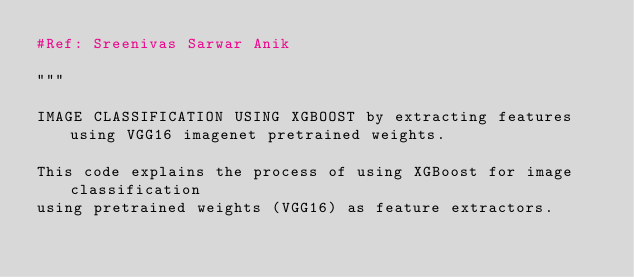<code> <loc_0><loc_0><loc_500><loc_500><_Python_>#Ref: Sreenivas Sarwar Anik

"""

IMAGE CLASSIFICATION USING XGBOOST by extracting features using VGG16 imagenet pretrained weights.

This code explains the process of using XGBoost for image classification
using pretrained weights (VGG16) as feature extractors.
</code> 